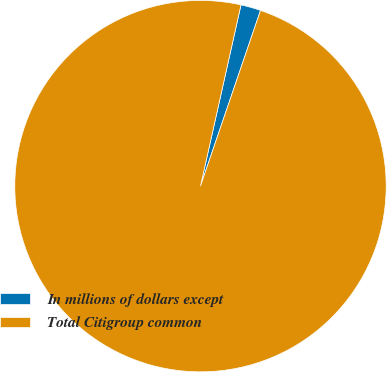Convert chart. <chart><loc_0><loc_0><loc_500><loc_500><pie_chart><fcel>In millions of dollars except<fcel>Total Citigroup common<nl><fcel>1.74%<fcel>98.26%<nl></chart> 